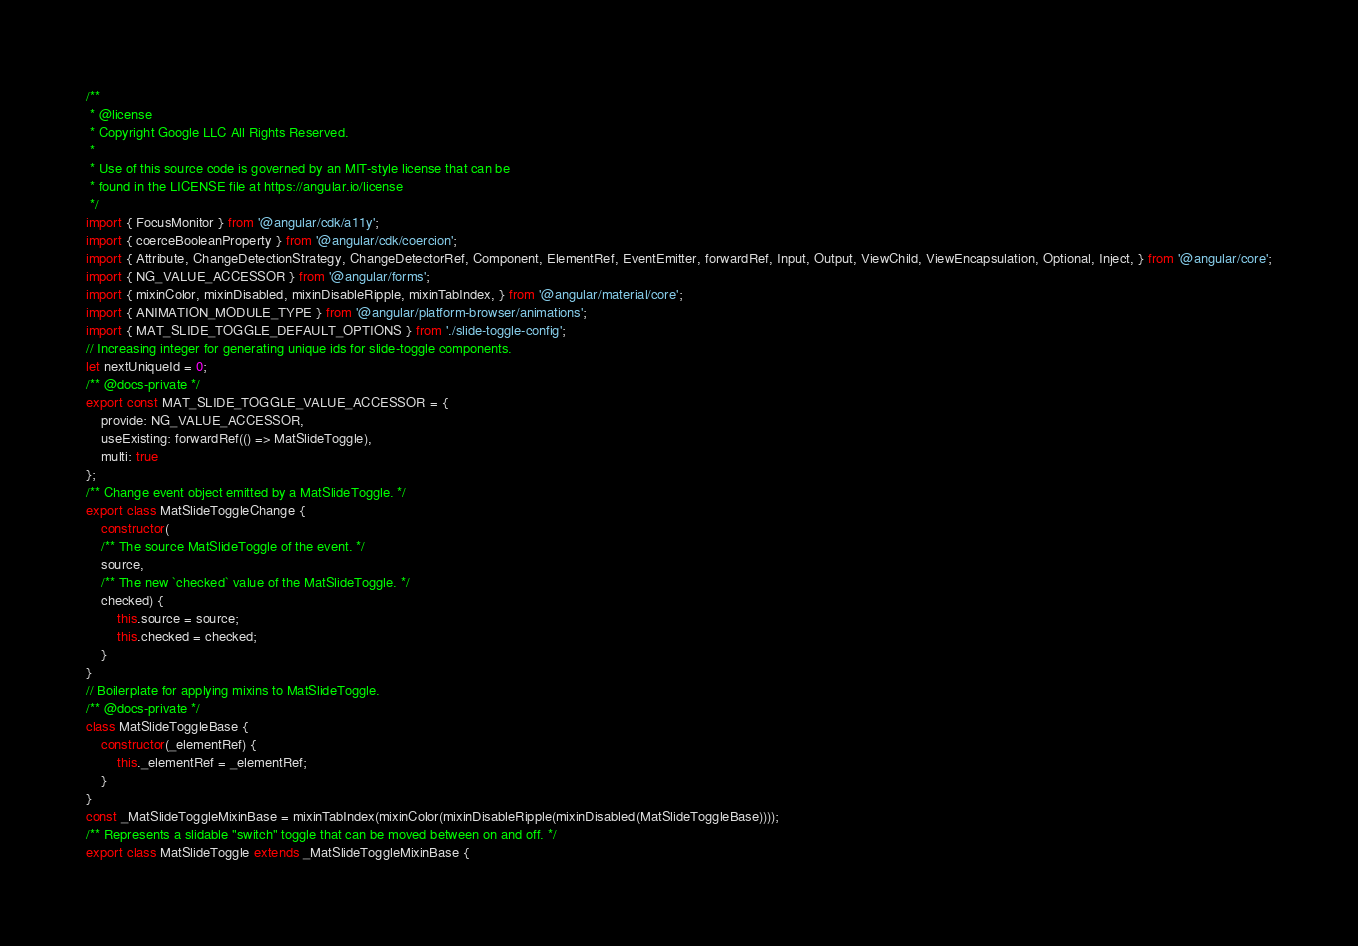Convert code to text. <code><loc_0><loc_0><loc_500><loc_500><_JavaScript_>/**
 * @license
 * Copyright Google LLC All Rights Reserved.
 *
 * Use of this source code is governed by an MIT-style license that can be
 * found in the LICENSE file at https://angular.io/license
 */
import { FocusMonitor } from '@angular/cdk/a11y';
import { coerceBooleanProperty } from '@angular/cdk/coercion';
import { Attribute, ChangeDetectionStrategy, ChangeDetectorRef, Component, ElementRef, EventEmitter, forwardRef, Input, Output, ViewChild, ViewEncapsulation, Optional, Inject, } from '@angular/core';
import { NG_VALUE_ACCESSOR } from '@angular/forms';
import { mixinColor, mixinDisabled, mixinDisableRipple, mixinTabIndex, } from '@angular/material/core';
import { ANIMATION_MODULE_TYPE } from '@angular/platform-browser/animations';
import { MAT_SLIDE_TOGGLE_DEFAULT_OPTIONS } from './slide-toggle-config';
// Increasing integer for generating unique ids for slide-toggle components.
let nextUniqueId = 0;
/** @docs-private */
export const MAT_SLIDE_TOGGLE_VALUE_ACCESSOR = {
    provide: NG_VALUE_ACCESSOR,
    useExisting: forwardRef(() => MatSlideToggle),
    multi: true
};
/** Change event object emitted by a MatSlideToggle. */
export class MatSlideToggleChange {
    constructor(
    /** The source MatSlideToggle of the event. */
    source, 
    /** The new `checked` value of the MatSlideToggle. */
    checked) {
        this.source = source;
        this.checked = checked;
    }
}
// Boilerplate for applying mixins to MatSlideToggle.
/** @docs-private */
class MatSlideToggleBase {
    constructor(_elementRef) {
        this._elementRef = _elementRef;
    }
}
const _MatSlideToggleMixinBase = mixinTabIndex(mixinColor(mixinDisableRipple(mixinDisabled(MatSlideToggleBase))));
/** Represents a slidable "switch" toggle that can be moved between on and off. */
export class MatSlideToggle extends _MatSlideToggleMixinBase {</code> 